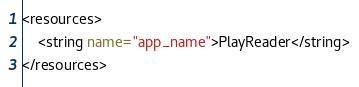<code> <loc_0><loc_0><loc_500><loc_500><_XML_><resources>
    <string name="app_name">PlayReader</string>
</resources>
</code> 